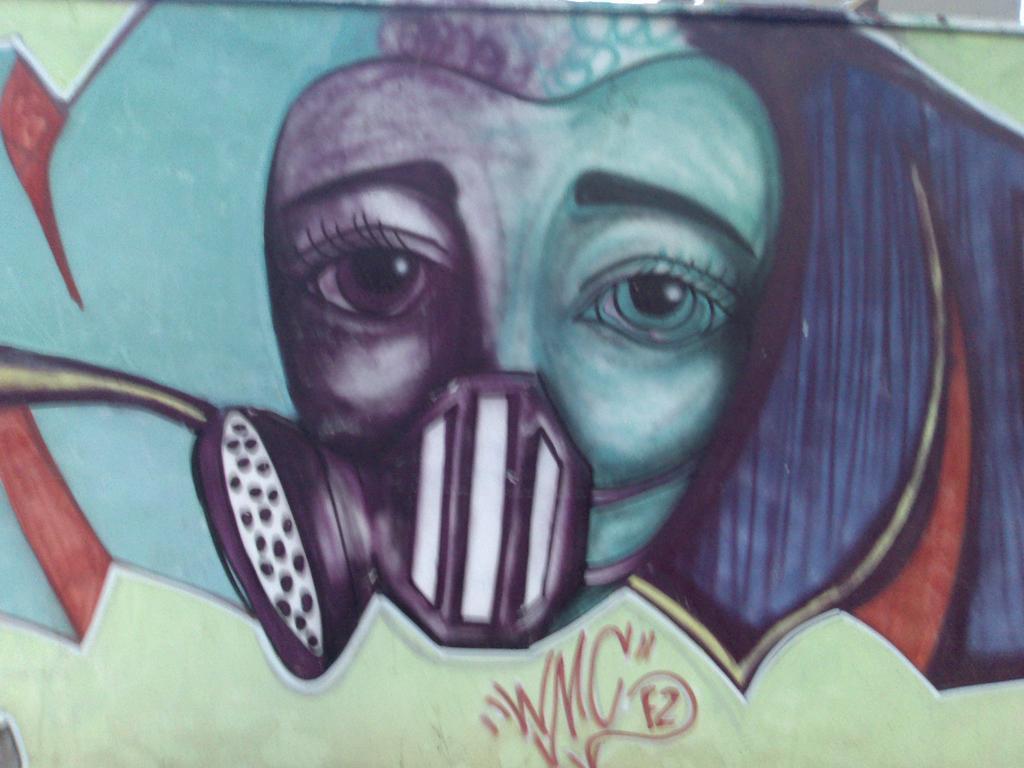Can you describe this image briefly? In this picture, there is a wall with a painting of a face. 